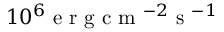Convert formula to latex. <formula><loc_0><loc_0><loc_500><loc_500>1 0 ^ { 6 } e r g c m ^ { - 2 } s ^ { - 1 }</formula> 